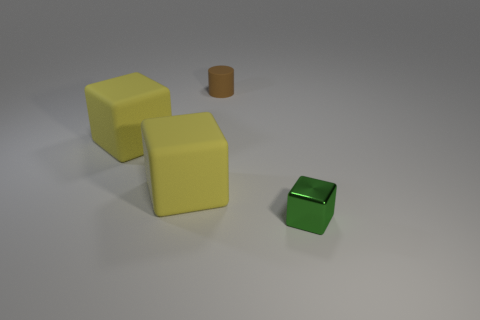Subtract all red cylinders. Subtract all blue cubes. How many cylinders are left? 1 Add 1 small brown things. How many objects exist? 5 Subtract all cubes. How many objects are left? 1 Add 3 brown objects. How many brown objects are left? 4 Add 1 tiny green objects. How many tiny green objects exist? 2 Subtract 0 gray balls. How many objects are left? 4 Subtract all large blocks. Subtract all big yellow matte blocks. How many objects are left? 0 